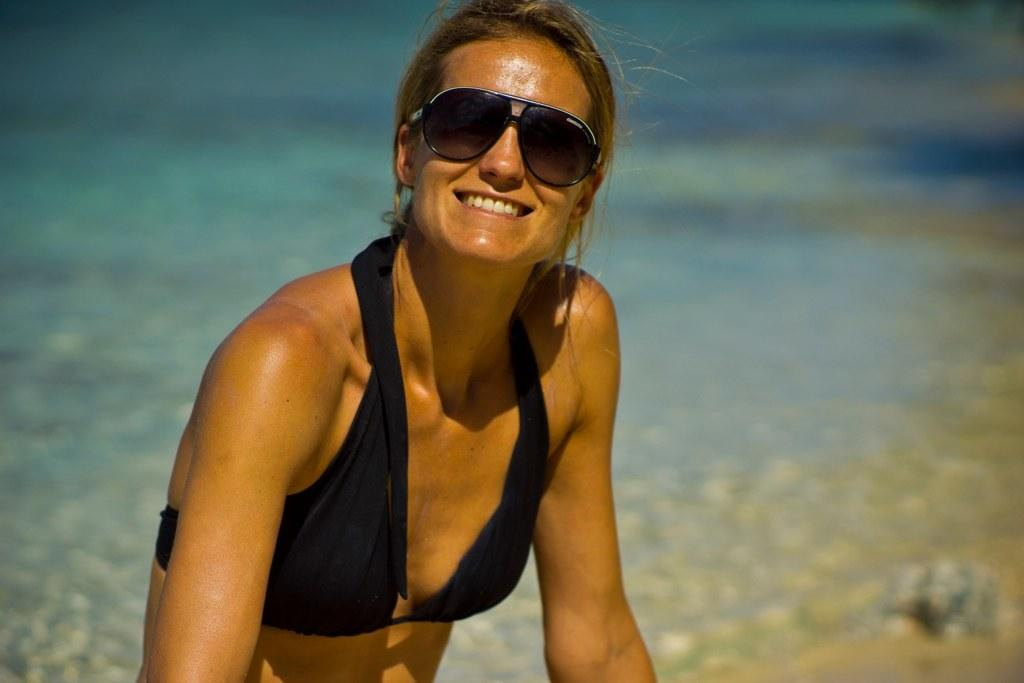Who is present in the image? There is a woman in the image. What is the woman's facial expression? The woman is smiling. What accessory is the woman wearing? The woman is wearing goggles. Can you describe the background of the image? The background of the image is blurred. What type of pickle is the woman holding in the image? There is no pickle present in the image; the woman is wearing goggles and smiling. 